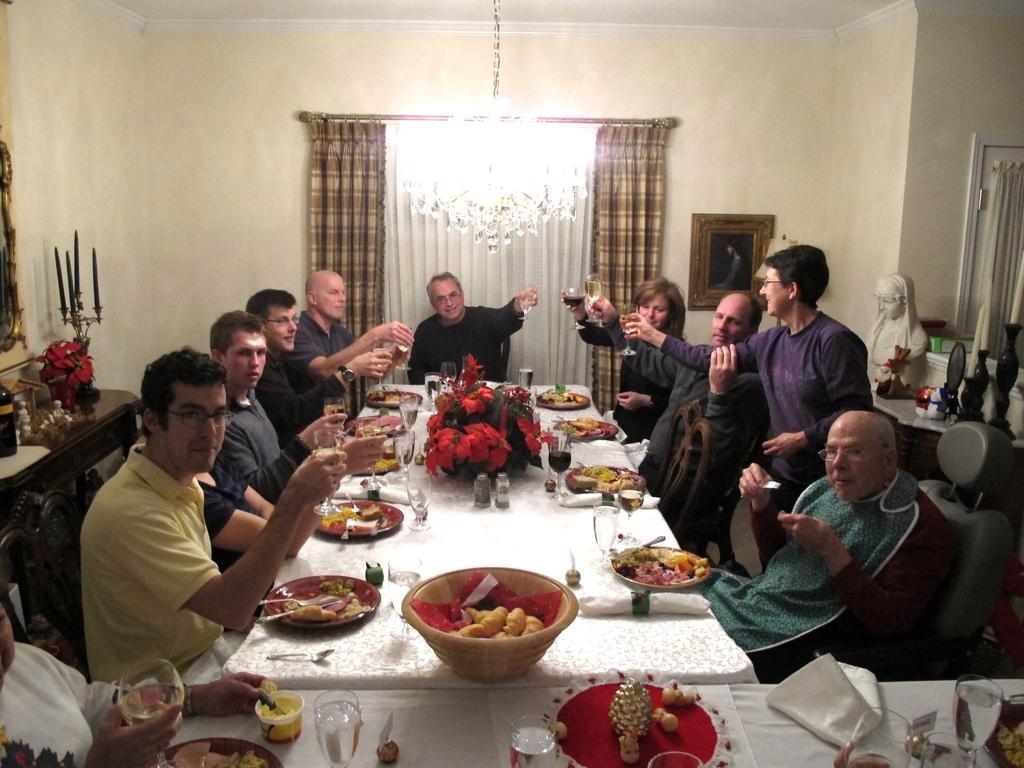Could you give a brief overview of what you see in this image? A picture inside of a room. This persons are sitting on a chair. In-front of this person's there is a table, on a table there are plates, glasses, bowl and food. This persons are holding a glass. Light is attached to the rooftop. On table there are candles and things. A white statue. A picture on a wall. A curtain with window. 